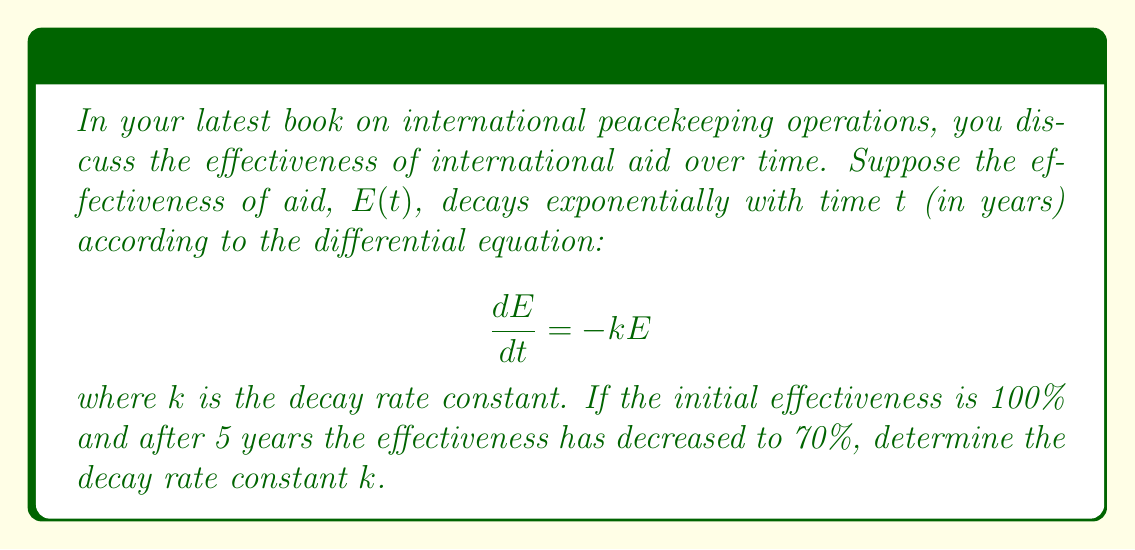Show me your answer to this math problem. To solve this problem, we'll follow these steps:

1) The general solution to the given differential equation is:
   $$E(t) = E_0e^{-kt}$$
   where $E_0$ is the initial effectiveness.

2) We're given that $E_0 = 100\%$ (initial effectiveness) and after 5 years, $E(5) = 70\%$.

3) Let's substitute these values into the general solution:
   $$70 = 100e^{-5k}$$

4) Divide both sides by 100:
   $$0.7 = e^{-5k}$$

5) Take the natural logarithm of both sides:
   $$\ln(0.7) = -5k$$

6) Solve for $k$:
   $$k = -\frac{\ln(0.7)}{5}$$

7) Calculate the value:
   $$k = -\frac{\ln(0.7)}{5} \approx 0.0713$$

The decay rate constant $k$ represents the proportion of effectiveness lost per year. To express this as a percentage, we multiply by 100:

$$0.0713 \times 100 \approx 7.13\%$$
Answer: The decay rate constant $k$ is approximately 0.0713, or 7.13% per year. 